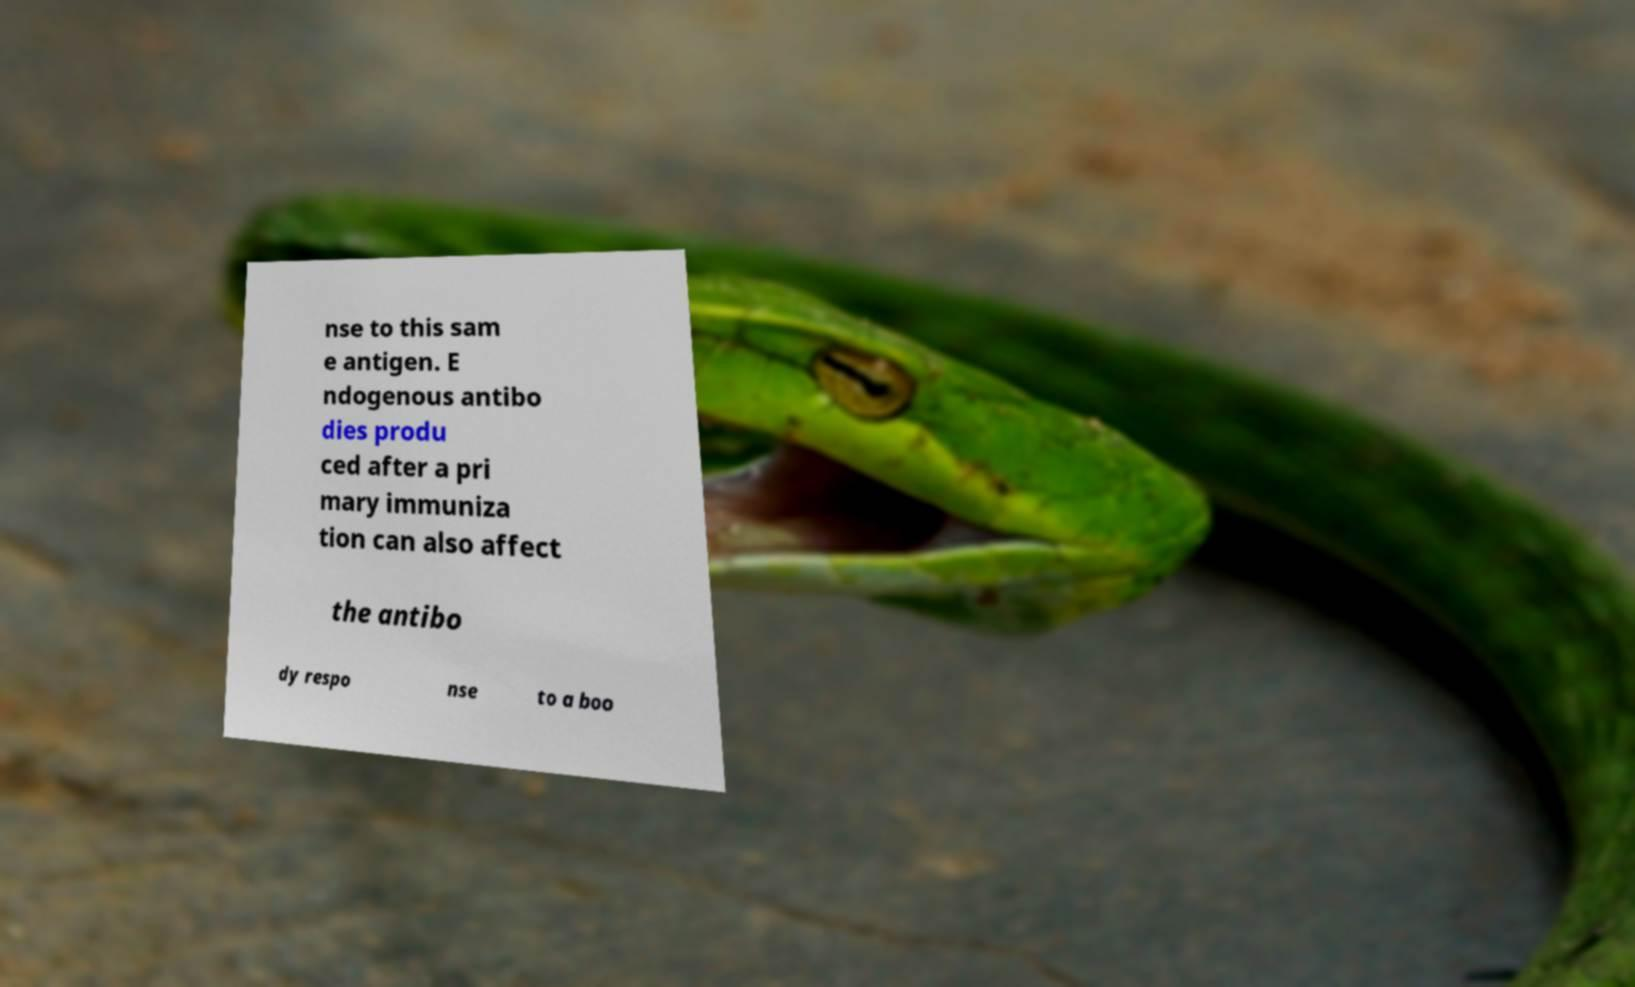I need the written content from this picture converted into text. Can you do that? nse to this sam e antigen. E ndogenous antibo dies produ ced after a pri mary immuniza tion can also affect the antibo dy respo nse to a boo 